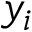Convert formula to latex. <formula><loc_0><loc_0><loc_500><loc_500>y _ { i }</formula> 